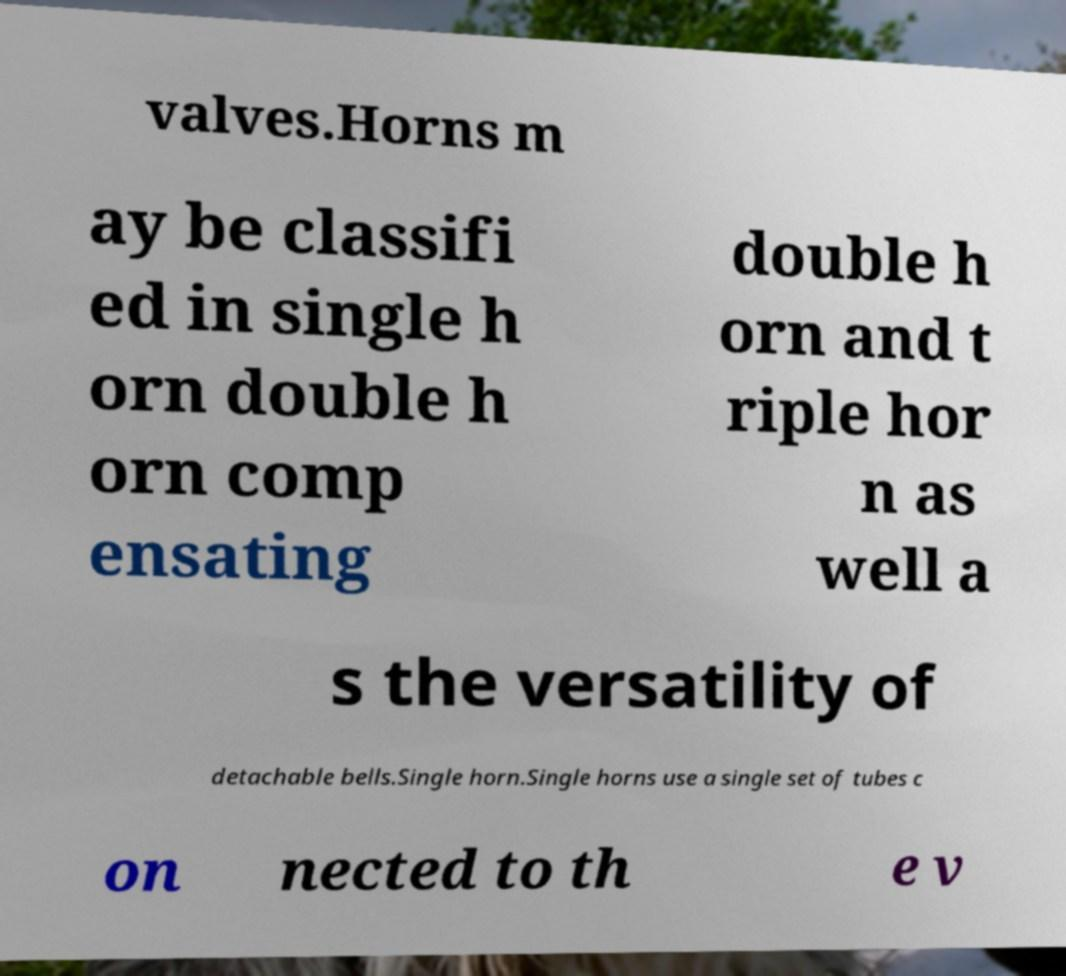Can you accurately transcribe the text from the provided image for me? valves.Horns m ay be classifi ed in single h orn double h orn comp ensating double h orn and t riple hor n as well a s the versatility of detachable bells.Single horn.Single horns use a single set of tubes c on nected to th e v 